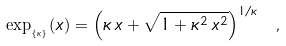Convert formula to latex. <formula><loc_0><loc_0><loc_500><loc_500>\exp _ { _ { \{ \kappa \} } } ( x ) = \left ( \kappa \, x + \sqrt { 1 + \kappa ^ { 2 } \, x ^ { 2 } } \right ) ^ { 1 / \kappa } \ ,</formula> 